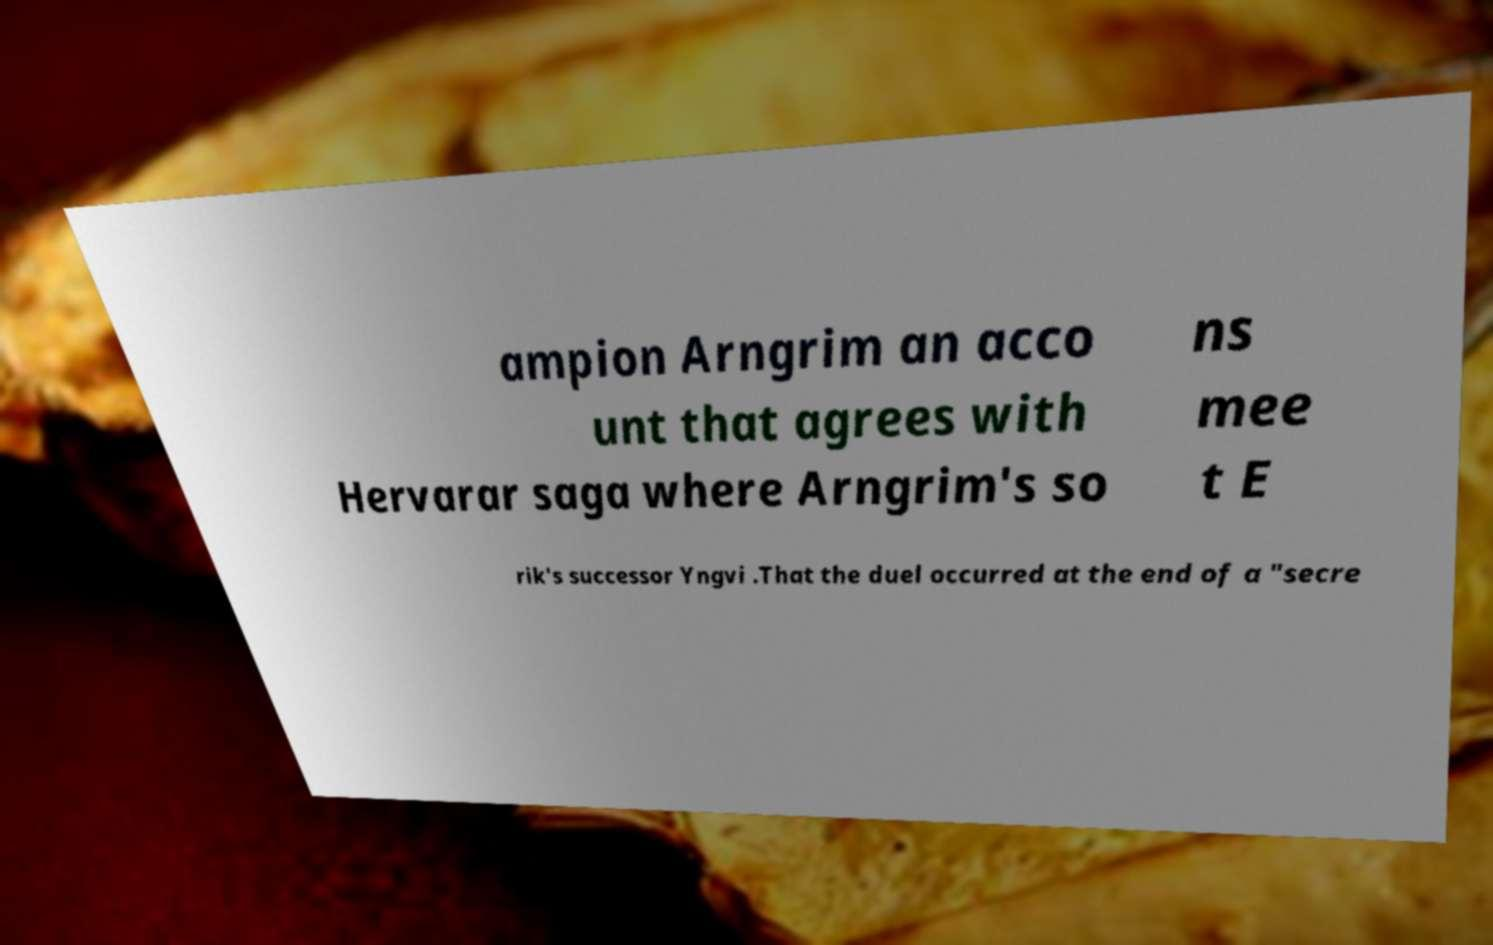I need the written content from this picture converted into text. Can you do that? ampion Arngrim an acco unt that agrees with Hervarar saga where Arngrim's so ns mee t E rik's successor Yngvi .That the duel occurred at the end of a "secre 